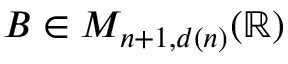<formula> <loc_0><loc_0><loc_500><loc_500>B \in M _ { n + 1 , d ( n ) } ( \mathbb { R } )</formula> 